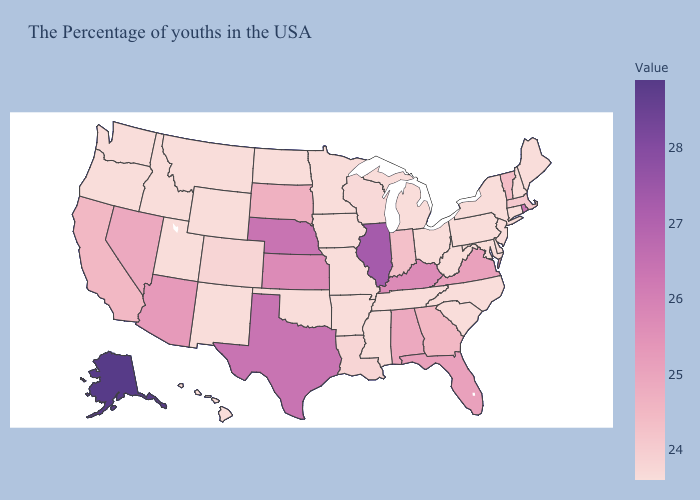Does Massachusetts have the highest value in the USA?
Give a very brief answer. No. Among the states that border Minnesota , which have the lowest value?
Concise answer only. Iowa, North Dakota. Does Indiana have the highest value in the MidWest?
Be succinct. No. Is the legend a continuous bar?
Write a very short answer. Yes. 